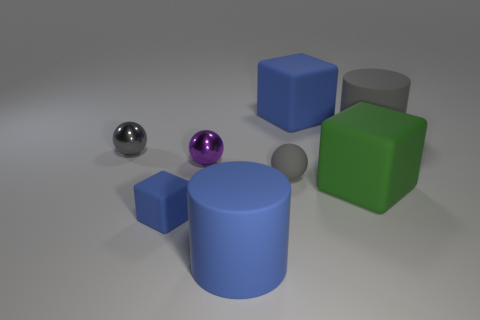Subtract all gray balls. Subtract all gray cylinders. How many balls are left? 1 Add 1 small cubes. How many objects exist? 9 Subtract all blocks. How many objects are left? 5 Subtract 0 yellow balls. How many objects are left? 8 Subtract all green things. Subtract all purple spheres. How many objects are left? 6 Add 3 green objects. How many green objects are left? 4 Add 4 purple balls. How many purple balls exist? 5 